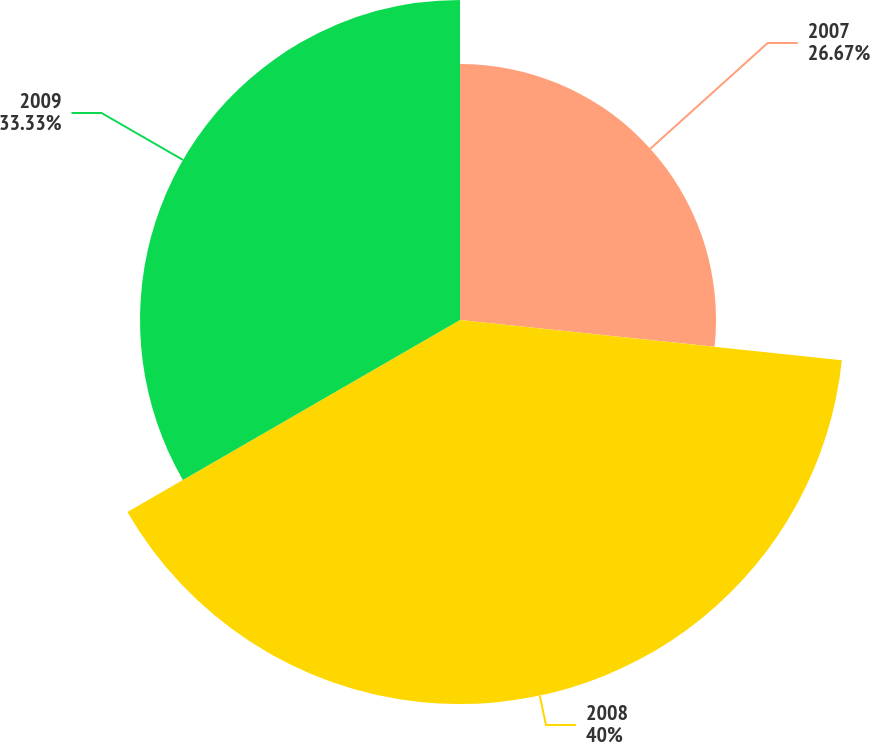Convert chart to OTSL. <chart><loc_0><loc_0><loc_500><loc_500><pie_chart><fcel>2007<fcel>2008<fcel>2009<nl><fcel>26.67%<fcel>40.0%<fcel>33.33%<nl></chart> 